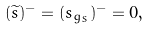<formula> <loc_0><loc_0><loc_500><loc_500>( \widetilde { s } ) ^ { - } = ( s _ { g _ { S } } ) ^ { - } = 0 ,</formula> 